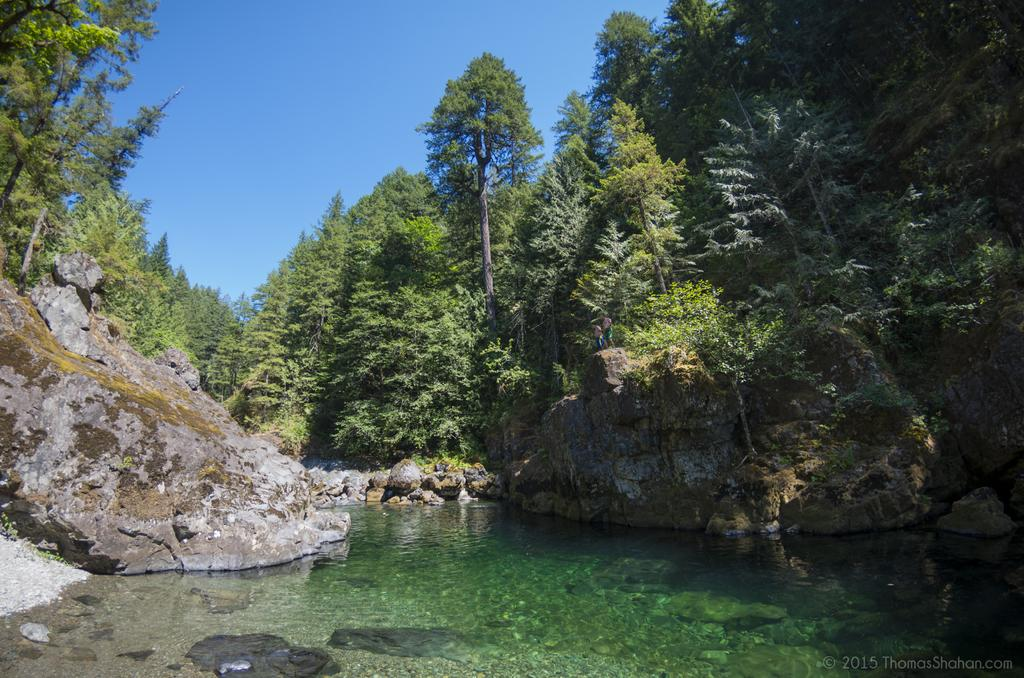What is the main subject in the center of the image? There is water in the center of the image. Are there any objects or features within the water? Yes, there are rocks in the water. What can be seen in the background of the image? There are trees and the sky visible in the background of the image. Can you see a needle in the image? No, there is no needle present in the image. What type of mountain can be seen in the image? There is no mountain present in the image. 